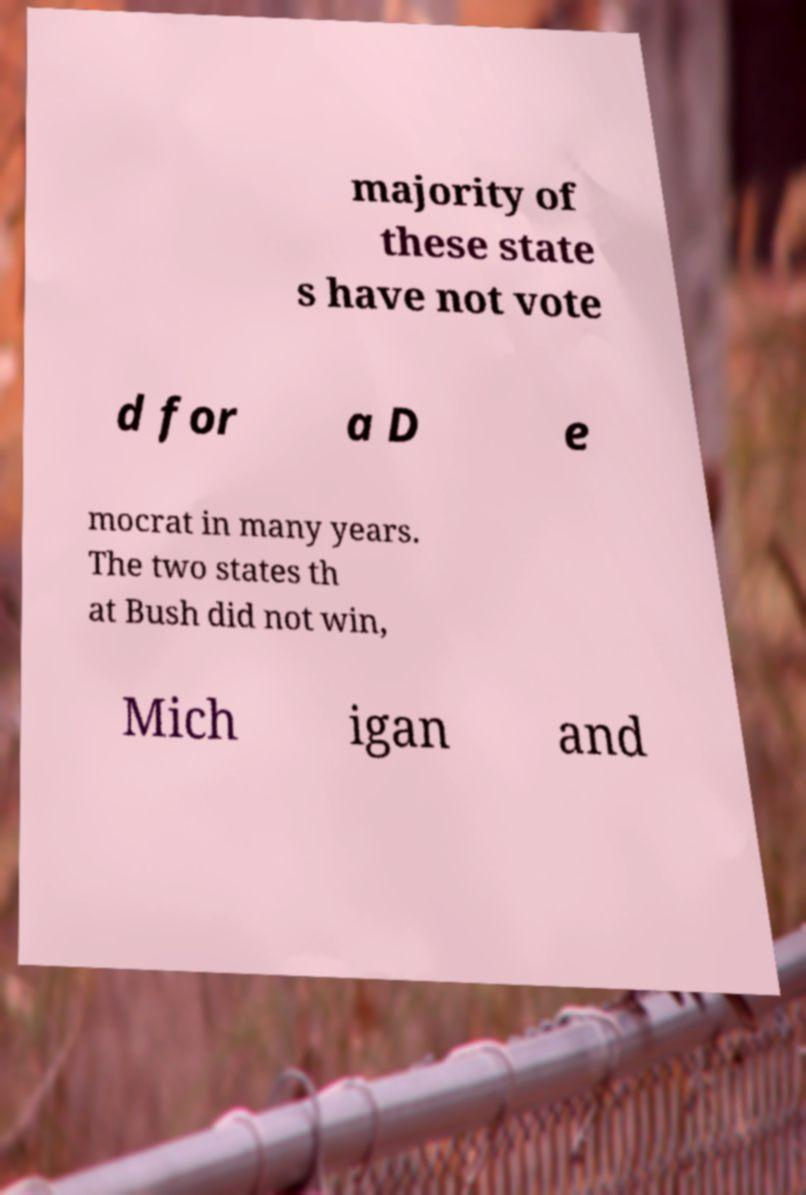There's text embedded in this image that I need extracted. Can you transcribe it verbatim? majority of these state s have not vote d for a D e mocrat in many years. The two states th at Bush did not win, Mich igan and 